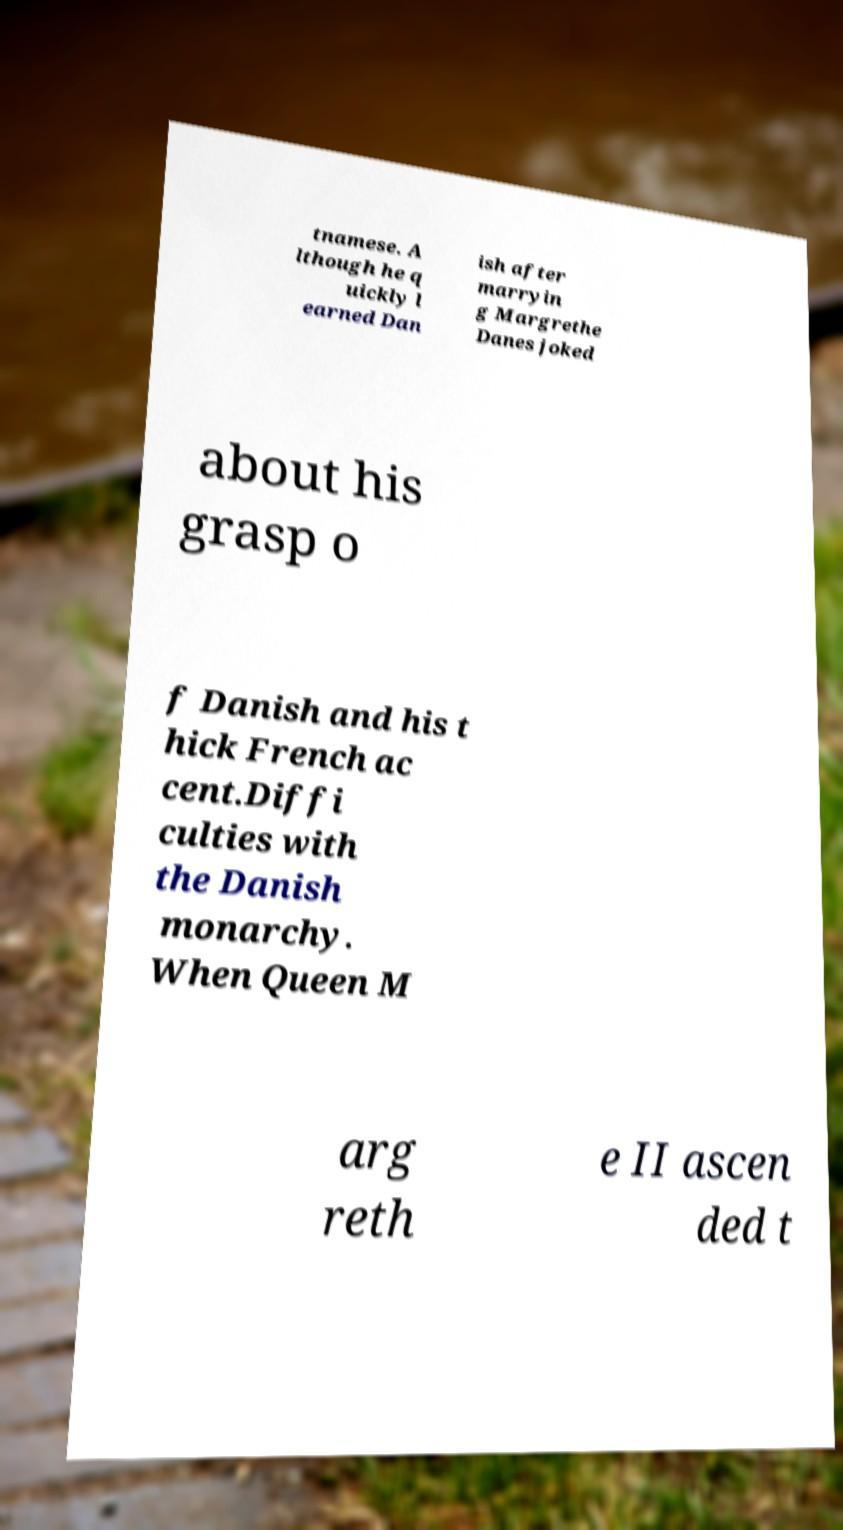Please read and relay the text visible in this image. What does it say? tnamese. A lthough he q uickly l earned Dan ish after marryin g Margrethe Danes joked about his grasp o f Danish and his t hick French ac cent.Diffi culties with the Danish monarchy. When Queen M arg reth e II ascen ded t 